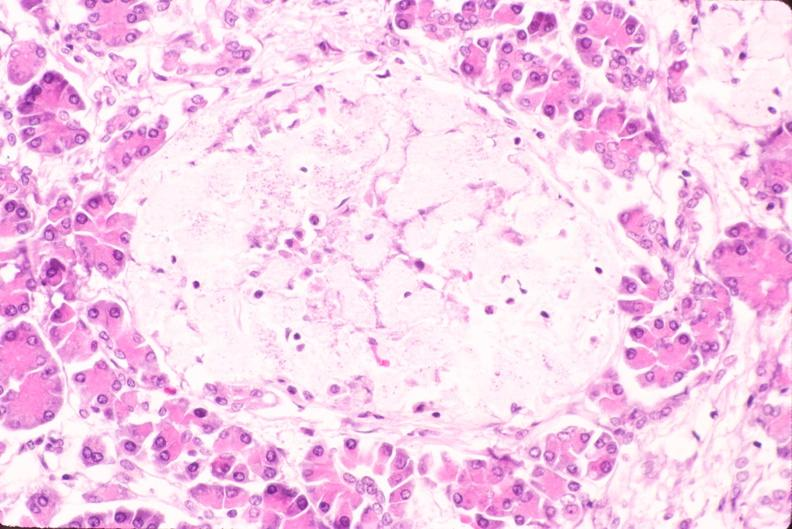does myocardium show pancreas, islet hyalinization, diabetes mellitus?
Answer the question using a single word or phrase. No 